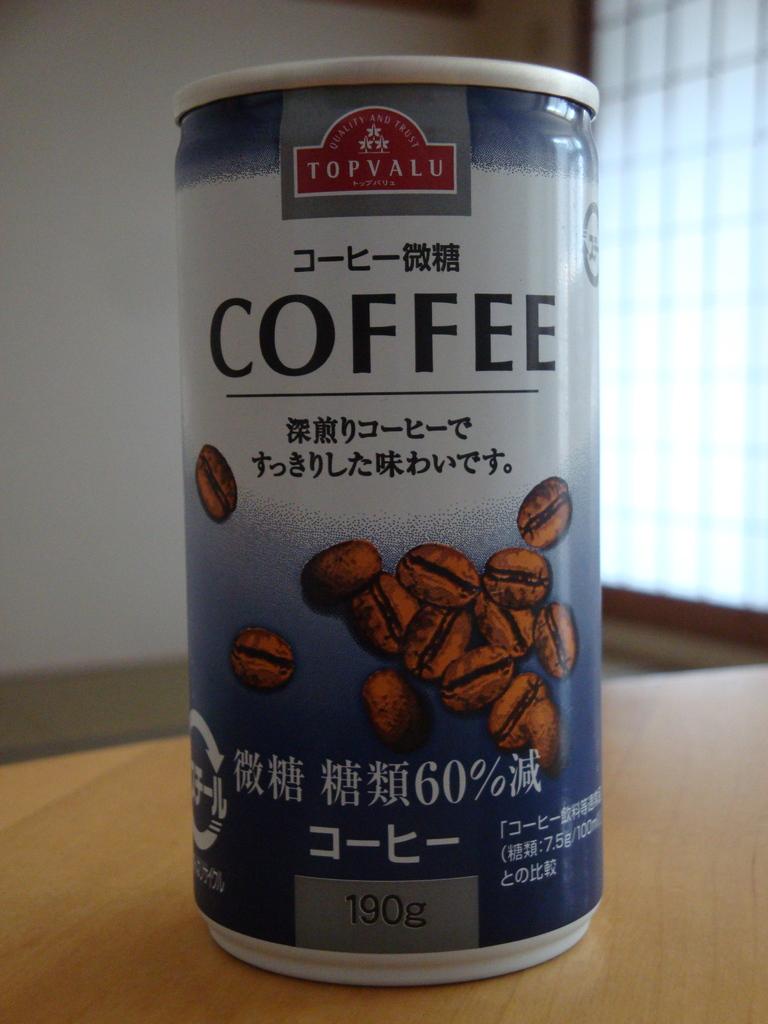What drink is in this can?
Offer a terse response. Coffee. What is the volume of the can?
Your response must be concise. 190g. 